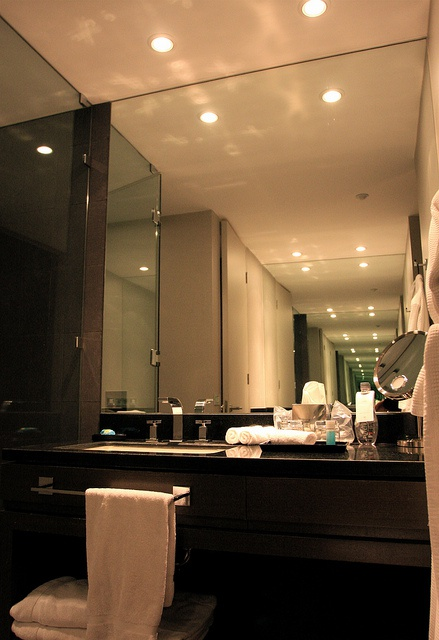Describe the objects in this image and their specific colors. I can see sink in gray, khaki, maroon, and black tones and bottle in gray, maroon, and black tones in this image. 